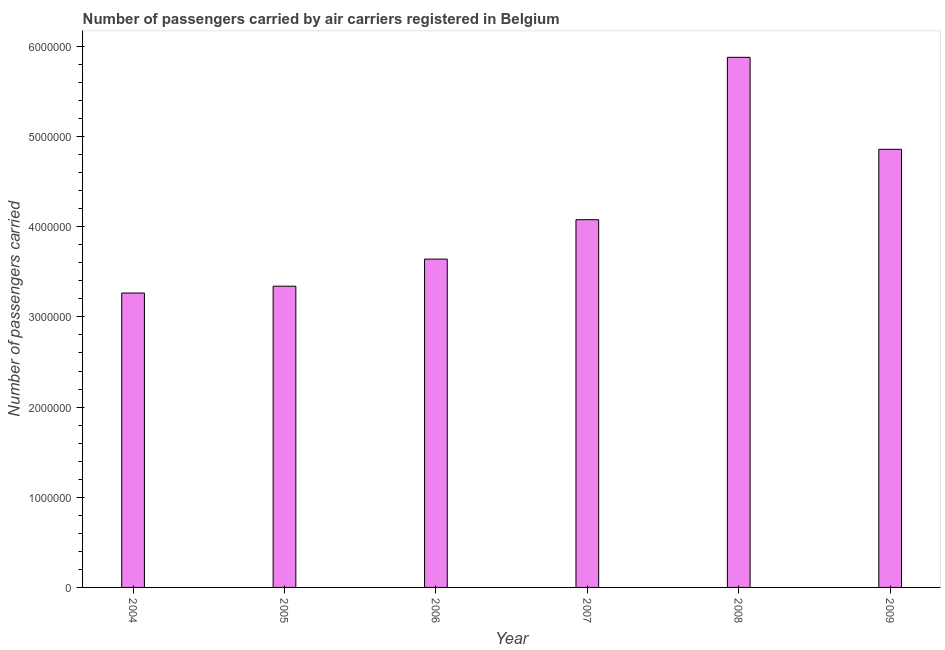What is the title of the graph?
Ensure brevity in your answer.  Number of passengers carried by air carriers registered in Belgium. What is the label or title of the X-axis?
Provide a succinct answer. Year. What is the label or title of the Y-axis?
Offer a very short reply. Number of passengers carried. What is the number of passengers carried in 2008?
Keep it short and to the point. 5.88e+06. Across all years, what is the maximum number of passengers carried?
Give a very brief answer. 5.88e+06. Across all years, what is the minimum number of passengers carried?
Provide a short and direct response. 3.26e+06. In which year was the number of passengers carried maximum?
Your response must be concise. 2008. In which year was the number of passengers carried minimum?
Provide a succinct answer. 2004. What is the sum of the number of passengers carried?
Make the answer very short. 2.51e+07. What is the difference between the number of passengers carried in 2007 and 2009?
Provide a succinct answer. -7.81e+05. What is the average number of passengers carried per year?
Provide a succinct answer. 4.18e+06. What is the median number of passengers carried?
Make the answer very short. 3.86e+06. Do a majority of the years between 2007 and 2005 (inclusive) have number of passengers carried greater than 3600000 ?
Give a very brief answer. Yes. What is the ratio of the number of passengers carried in 2006 to that in 2008?
Provide a succinct answer. 0.62. Is the number of passengers carried in 2004 less than that in 2008?
Offer a terse response. Yes. What is the difference between the highest and the second highest number of passengers carried?
Offer a very short reply. 1.02e+06. What is the difference between the highest and the lowest number of passengers carried?
Provide a short and direct response. 2.61e+06. How many years are there in the graph?
Your answer should be very brief. 6. Are the values on the major ticks of Y-axis written in scientific E-notation?
Your response must be concise. No. What is the Number of passengers carried in 2004?
Give a very brief answer. 3.26e+06. What is the Number of passengers carried of 2005?
Your response must be concise. 3.34e+06. What is the Number of passengers carried in 2006?
Offer a terse response. 3.64e+06. What is the Number of passengers carried of 2007?
Provide a succinct answer. 4.08e+06. What is the Number of passengers carried of 2008?
Provide a succinct answer. 5.88e+06. What is the Number of passengers carried of 2009?
Keep it short and to the point. 4.86e+06. What is the difference between the Number of passengers carried in 2004 and 2005?
Provide a short and direct response. -7.59e+04. What is the difference between the Number of passengers carried in 2004 and 2006?
Ensure brevity in your answer.  -3.77e+05. What is the difference between the Number of passengers carried in 2004 and 2007?
Provide a succinct answer. -8.14e+05. What is the difference between the Number of passengers carried in 2004 and 2008?
Offer a terse response. -2.61e+06. What is the difference between the Number of passengers carried in 2004 and 2009?
Provide a short and direct response. -1.59e+06. What is the difference between the Number of passengers carried in 2005 and 2006?
Give a very brief answer. -3.01e+05. What is the difference between the Number of passengers carried in 2005 and 2007?
Give a very brief answer. -7.38e+05. What is the difference between the Number of passengers carried in 2005 and 2008?
Ensure brevity in your answer.  -2.54e+06. What is the difference between the Number of passengers carried in 2005 and 2009?
Your response must be concise. -1.52e+06. What is the difference between the Number of passengers carried in 2006 and 2007?
Your response must be concise. -4.37e+05. What is the difference between the Number of passengers carried in 2006 and 2008?
Give a very brief answer. -2.24e+06. What is the difference between the Number of passengers carried in 2006 and 2009?
Give a very brief answer. -1.22e+06. What is the difference between the Number of passengers carried in 2007 and 2008?
Your answer should be very brief. -1.80e+06. What is the difference between the Number of passengers carried in 2007 and 2009?
Your answer should be very brief. -7.81e+05. What is the difference between the Number of passengers carried in 2008 and 2009?
Ensure brevity in your answer.  1.02e+06. What is the ratio of the Number of passengers carried in 2004 to that in 2005?
Offer a very short reply. 0.98. What is the ratio of the Number of passengers carried in 2004 to that in 2006?
Your answer should be compact. 0.9. What is the ratio of the Number of passengers carried in 2004 to that in 2007?
Provide a short and direct response. 0.8. What is the ratio of the Number of passengers carried in 2004 to that in 2008?
Your answer should be very brief. 0.56. What is the ratio of the Number of passengers carried in 2004 to that in 2009?
Your answer should be compact. 0.67. What is the ratio of the Number of passengers carried in 2005 to that in 2006?
Provide a succinct answer. 0.92. What is the ratio of the Number of passengers carried in 2005 to that in 2007?
Offer a very short reply. 0.82. What is the ratio of the Number of passengers carried in 2005 to that in 2008?
Provide a succinct answer. 0.57. What is the ratio of the Number of passengers carried in 2005 to that in 2009?
Provide a short and direct response. 0.69. What is the ratio of the Number of passengers carried in 2006 to that in 2007?
Keep it short and to the point. 0.89. What is the ratio of the Number of passengers carried in 2006 to that in 2008?
Make the answer very short. 0.62. What is the ratio of the Number of passengers carried in 2006 to that in 2009?
Provide a succinct answer. 0.75. What is the ratio of the Number of passengers carried in 2007 to that in 2008?
Make the answer very short. 0.69. What is the ratio of the Number of passengers carried in 2007 to that in 2009?
Your answer should be compact. 0.84. What is the ratio of the Number of passengers carried in 2008 to that in 2009?
Make the answer very short. 1.21. 